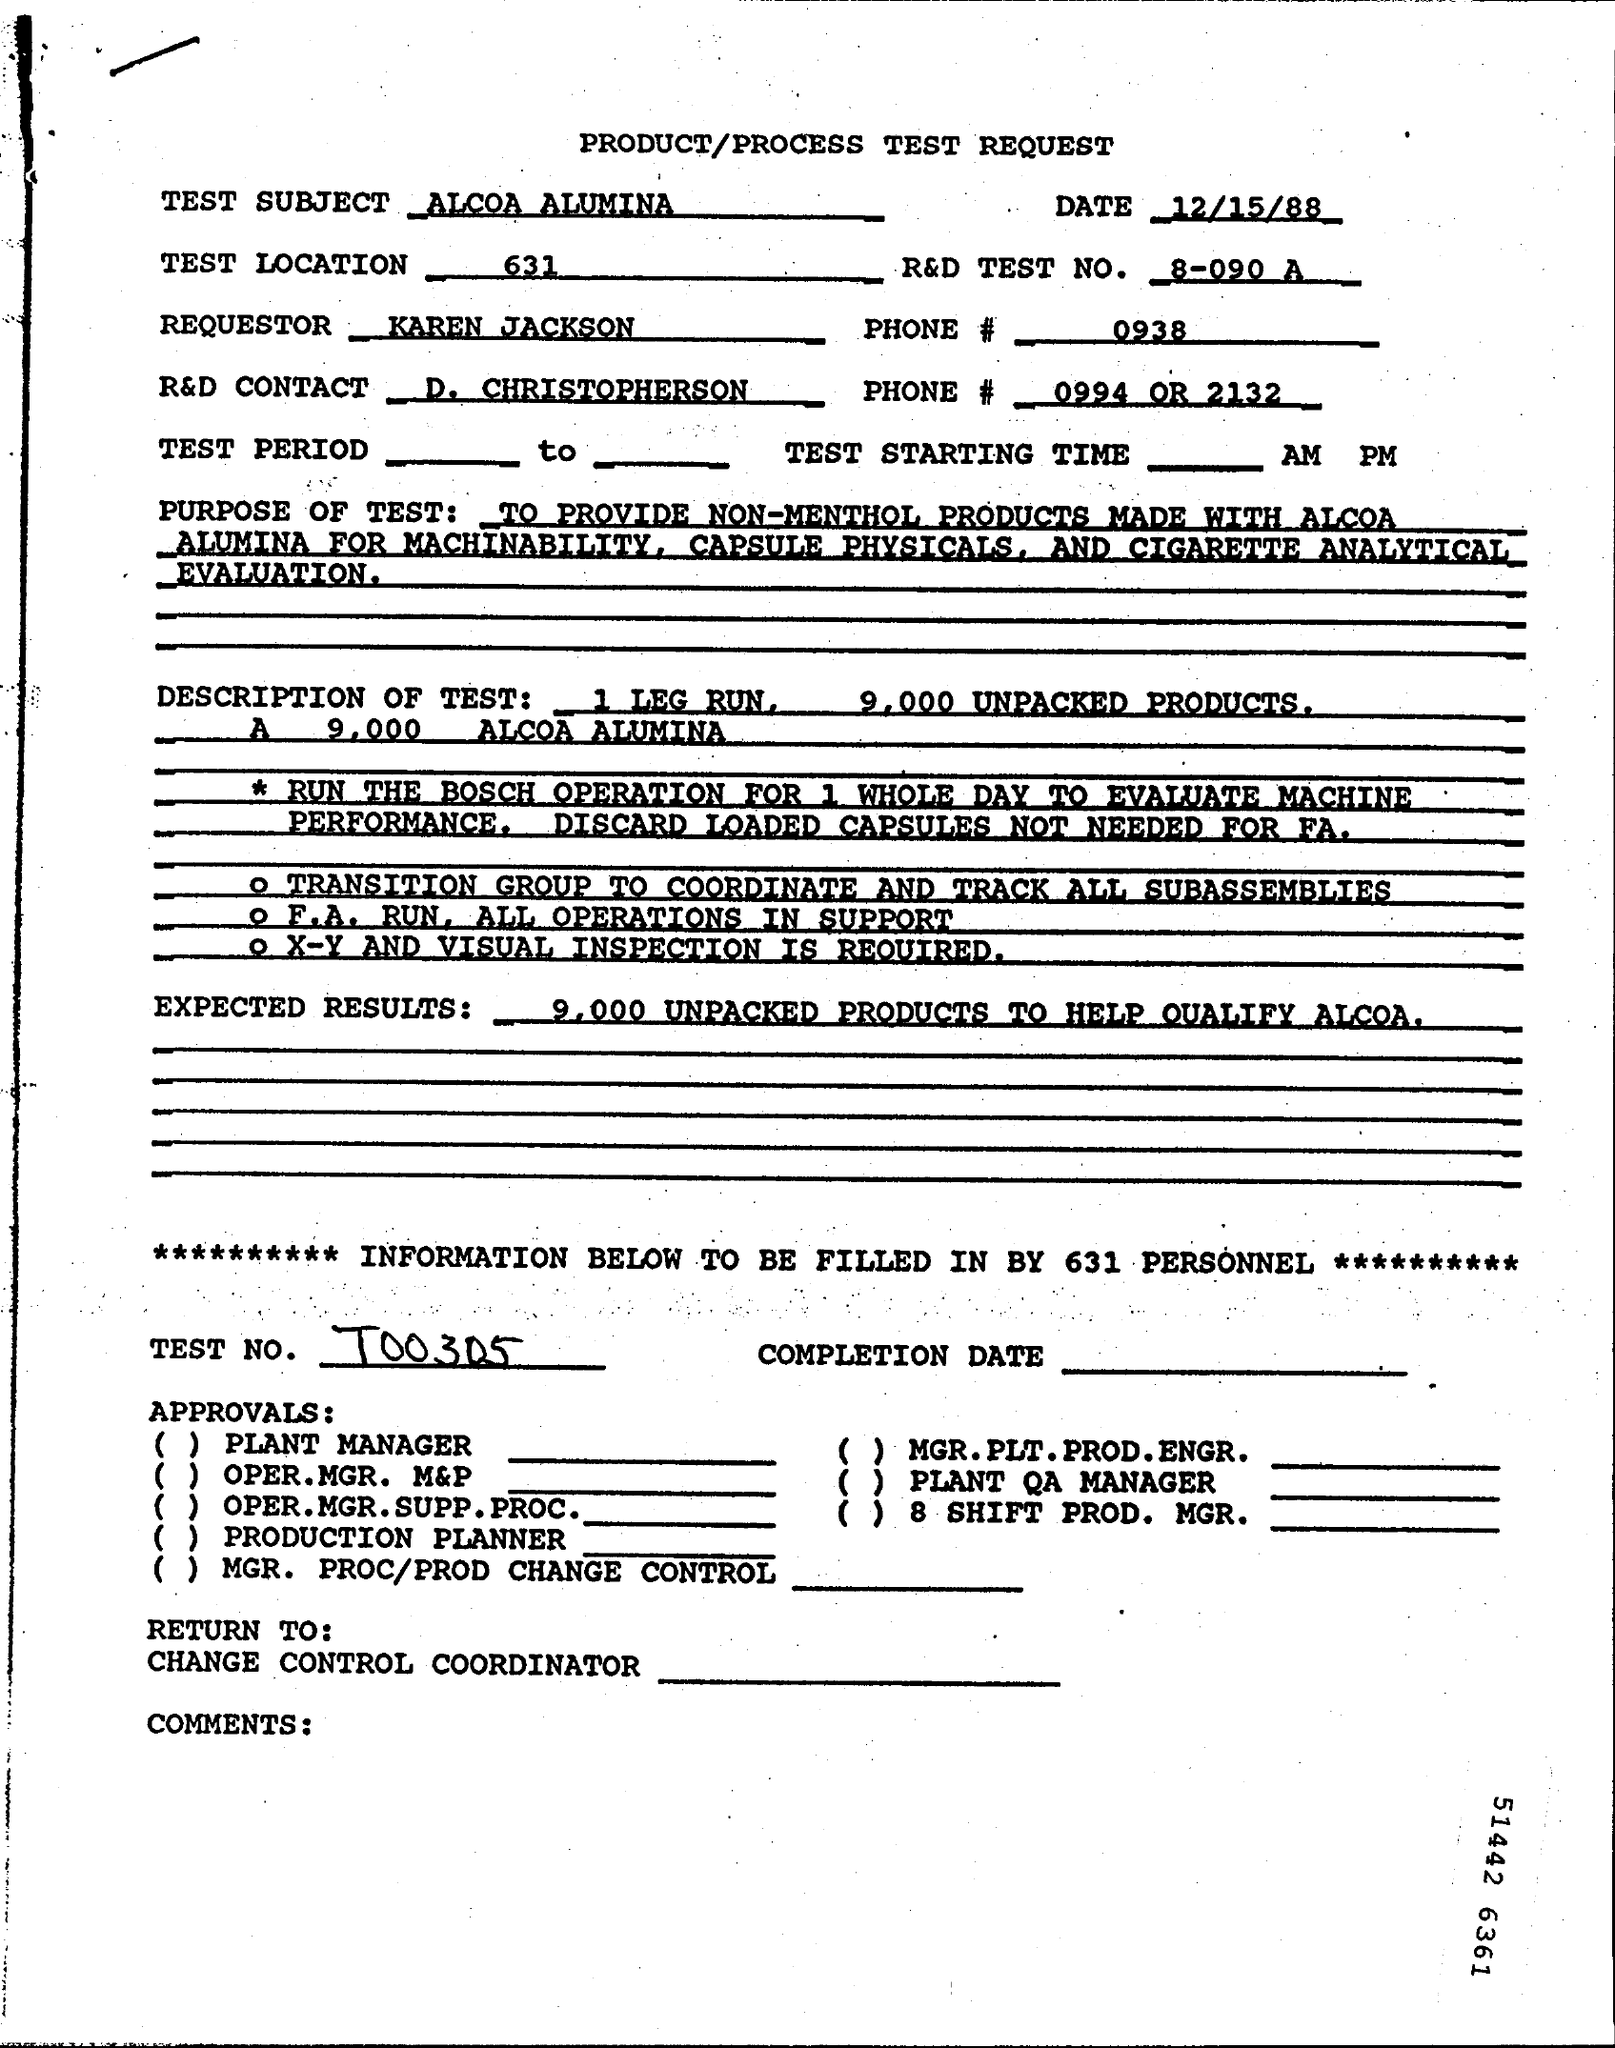List a handful of essential elements in this visual. The Test Location is 631. The date of the test request is December 15, 1988. 